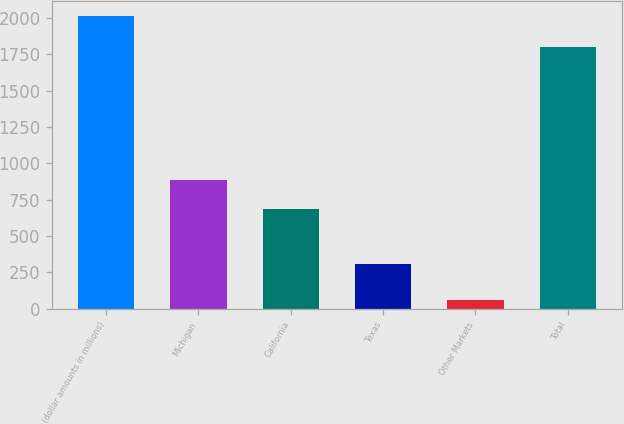Convert chart. <chart><loc_0><loc_0><loc_500><loc_500><bar_chart><fcel>(dollar amounts in millions)<fcel>Michigan<fcel>California<fcel>Texas<fcel>Other Markets<fcel>Total<nl><fcel>2016<fcel>882.6<fcel>687<fcel>305<fcel>60<fcel>1800<nl></chart> 